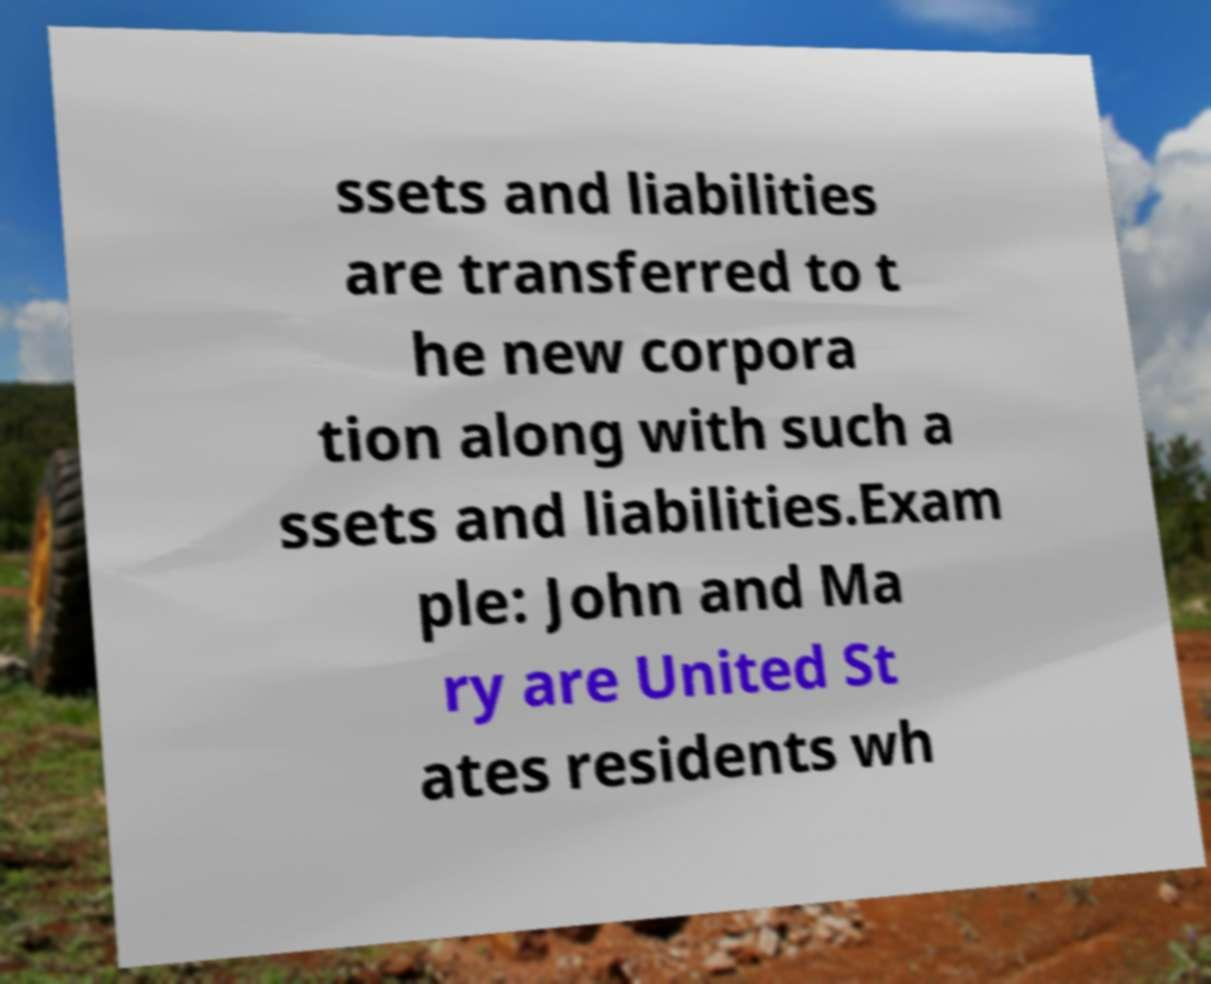Could you assist in decoding the text presented in this image and type it out clearly? ssets and liabilities are transferred to t he new corpora tion along with such a ssets and liabilities.Exam ple: John and Ma ry are United St ates residents wh 